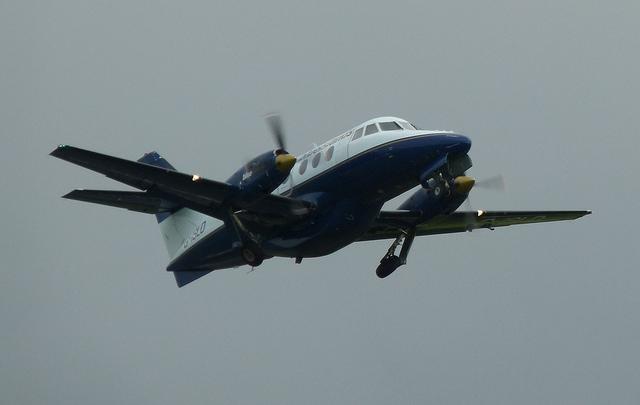What color is this plane?
Answer briefly. White and blue. Is this a twin engines jet?
Quick response, please. Yes. Is this a passenger jet?
Concise answer only. No. What color is the sky?
Quick response, please. Gray. Is the vehicle in motion or parked?
Keep it brief. In motion. Where is the plane?
Be succinct. In air. 